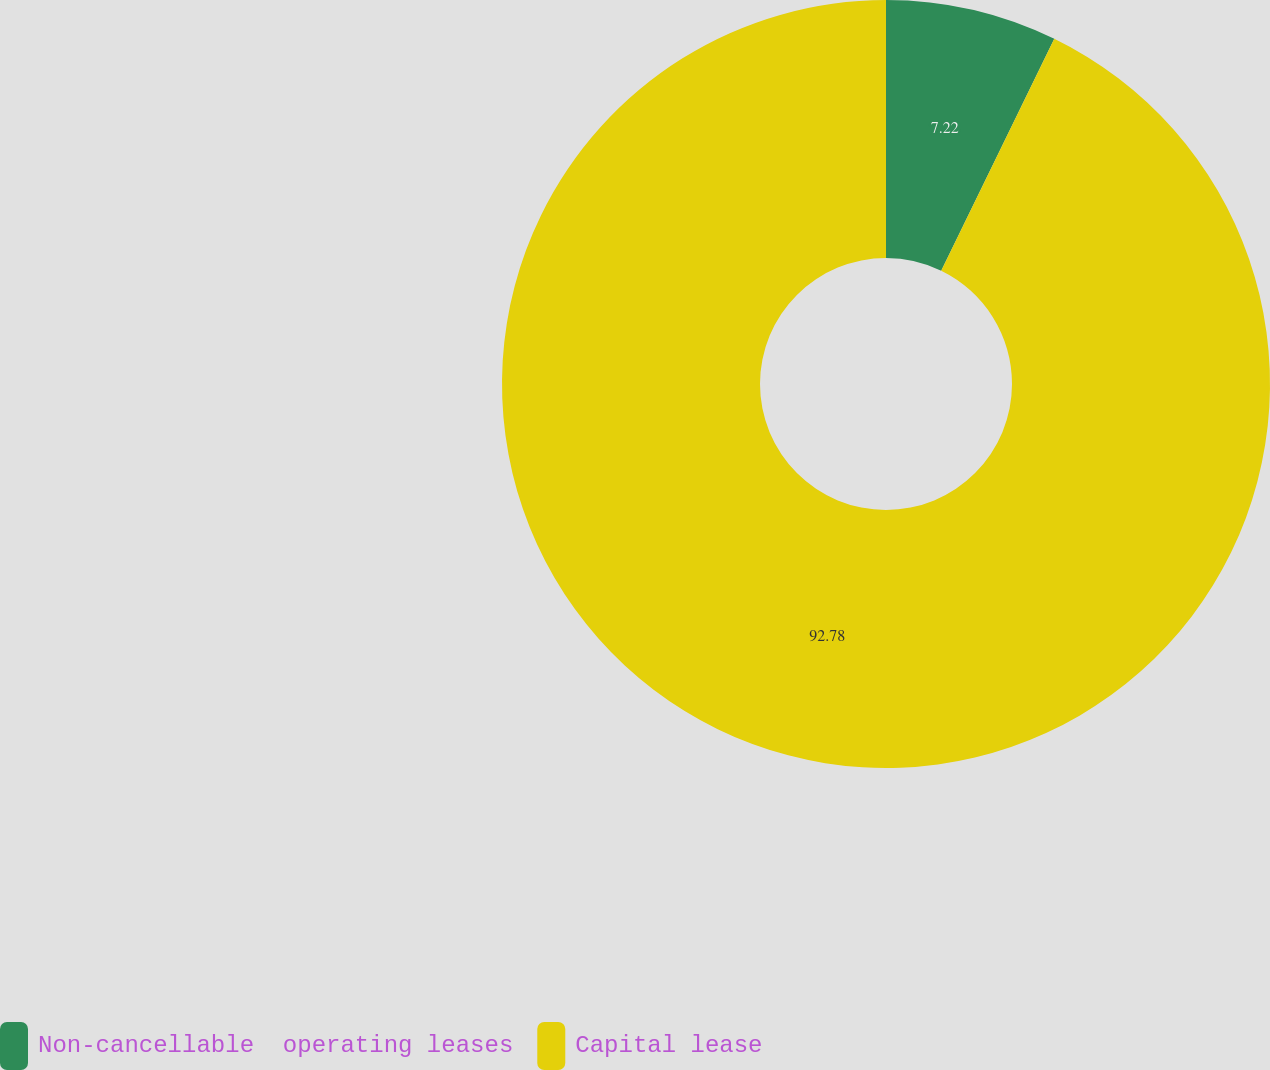Convert chart to OTSL. <chart><loc_0><loc_0><loc_500><loc_500><pie_chart><fcel>Non-cancellable  operating leases<fcel>Capital lease<nl><fcel>7.22%<fcel>92.78%<nl></chart> 